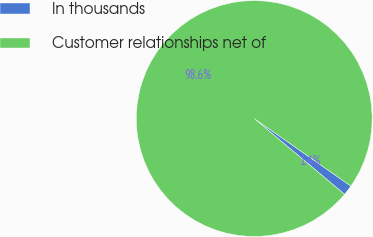Convert chart. <chart><loc_0><loc_0><loc_500><loc_500><pie_chart><fcel>In thousands<fcel>Customer relationships net of<nl><fcel>1.4%<fcel>98.6%<nl></chart> 